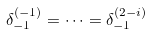<formula> <loc_0><loc_0><loc_500><loc_500>\delta _ { - 1 } ^ { ( - 1 ) } = \dots = \delta _ { - 1 } ^ { ( 2 - i ) }</formula> 